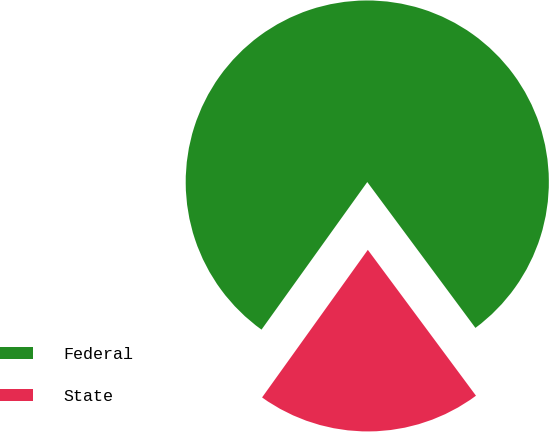Convert chart. <chart><loc_0><loc_0><loc_500><loc_500><pie_chart><fcel>Federal<fcel>State<nl><fcel>79.95%<fcel>20.05%<nl></chart> 